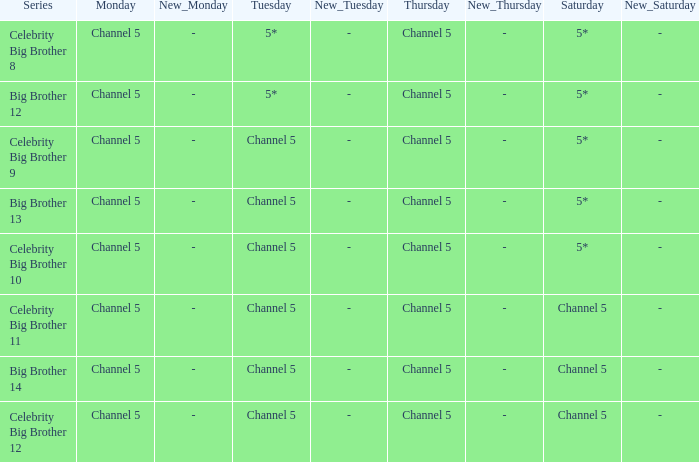Which Tuesday does big brother 12 air? 5*. 